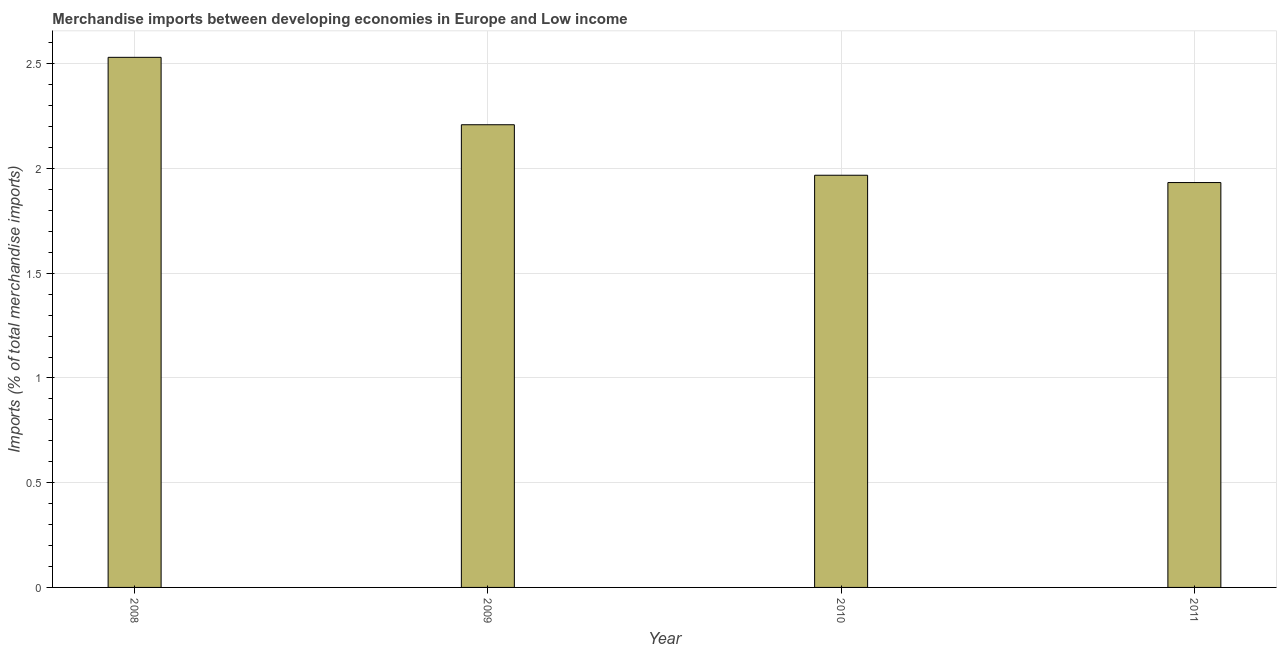Does the graph contain any zero values?
Provide a short and direct response. No. Does the graph contain grids?
Keep it short and to the point. Yes. What is the title of the graph?
Ensure brevity in your answer.  Merchandise imports between developing economies in Europe and Low income. What is the label or title of the X-axis?
Your answer should be compact. Year. What is the label or title of the Y-axis?
Offer a terse response. Imports (% of total merchandise imports). What is the merchandise imports in 2010?
Ensure brevity in your answer.  1.97. Across all years, what is the maximum merchandise imports?
Your answer should be very brief. 2.53. Across all years, what is the minimum merchandise imports?
Keep it short and to the point. 1.93. In which year was the merchandise imports maximum?
Provide a short and direct response. 2008. What is the sum of the merchandise imports?
Your answer should be very brief. 8.64. What is the difference between the merchandise imports in 2009 and 2011?
Your response must be concise. 0.28. What is the average merchandise imports per year?
Offer a very short reply. 2.16. What is the median merchandise imports?
Offer a terse response. 2.09. In how many years, is the merchandise imports greater than 1.8 %?
Your response must be concise. 4. Do a majority of the years between 2008 and 2011 (inclusive) have merchandise imports greater than 1.4 %?
Your response must be concise. Yes. What is the ratio of the merchandise imports in 2009 to that in 2010?
Provide a short and direct response. 1.12. Is the merchandise imports in 2008 less than that in 2010?
Provide a short and direct response. No. What is the difference between the highest and the second highest merchandise imports?
Keep it short and to the point. 0.32. Are all the bars in the graph horizontal?
Ensure brevity in your answer.  No. What is the Imports (% of total merchandise imports) in 2008?
Your answer should be compact. 2.53. What is the Imports (% of total merchandise imports) in 2009?
Make the answer very short. 2.21. What is the Imports (% of total merchandise imports) in 2010?
Your answer should be very brief. 1.97. What is the Imports (% of total merchandise imports) of 2011?
Offer a terse response. 1.93. What is the difference between the Imports (% of total merchandise imports) in 2008 and 2009?
Your answer should be compact. 0.32. What is the difference between the Imports (% of total merchandise imports) in 2008 and 2010?
Keep it short and to the point. 0.56. What is the difference between the Imports (% of total merchandise imports) in 2008 and 2011?
Your answer should be compact. 0.6. What is the difference between the Imports (% of total merchandise imports) in 2009 and 2010?
Your response must be concise. 0.24. What is the difference between the Imports (% of total merchandise imports) in 2009 and 2011?
Offer a very short reply. 0.28. What is the difference between the Imports (% of total merchandise imports) in 2010 and 2011?
Provide a succinct answer. 0.03. What is the ratio of the Imports (% of total merchandise imports) in 2008 to that in 2009?
Make the answer very short. 1.15. What is the ratio of the Imports (% of total merchandise imports) in 2008 to that in 2010?
Make the answer very short. 1.29. What is the ratio of the Imports (% of total merchandise imports) in 2008 to that in 2011?
Give a very brief answer. 1.31. What is the ratio of the Imports (% of total merchandise imports) in 2009 to that in 2010?
Your answer should be compact. 1.12. What is the ratio of the Imports (% of total merchandise imports) in 2009 to that in 2011?
Offer a very short reply. 1.14. 